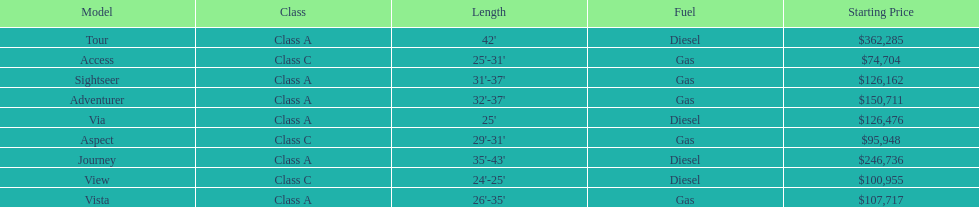What is the name of the top priced winnebago model? Tour. 